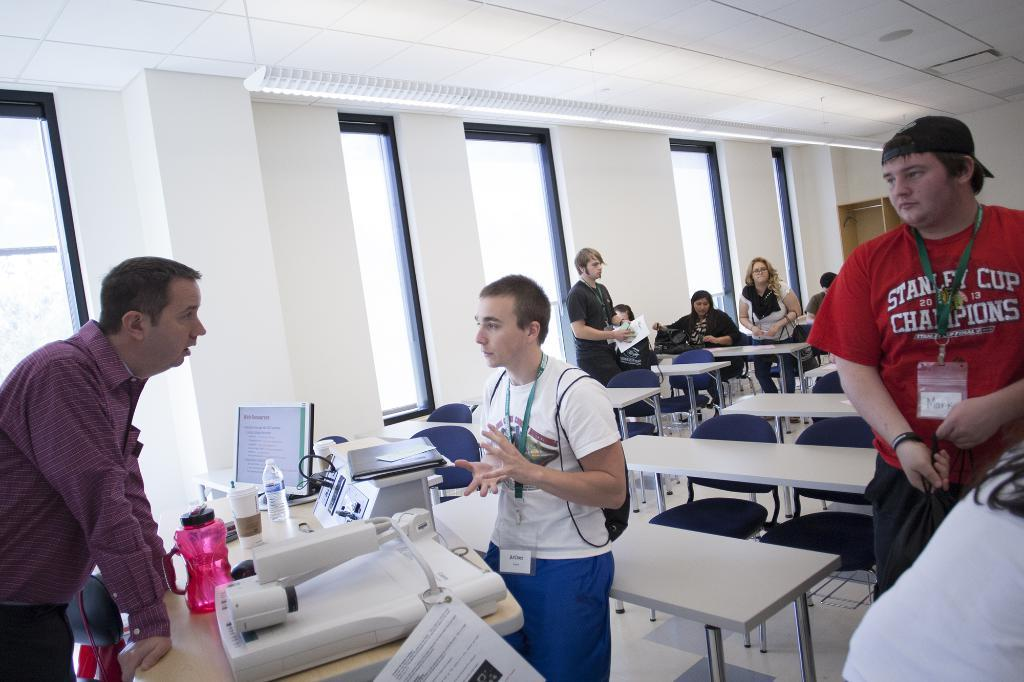What is the role of the person in the image? There is a teacher in the image. What is the teacher doing in the image? The teacher is explaining something. Who else is present in the image besides the teacher? There is at least one student in the image, and there are other students in the classroom. What is the location of the scene in the image? The setting is a classroom. What type of key is the teacher using to unlock the self in the image? There is no key or self present in the image; it depicts a teacher explaining something in a classroom setting. 